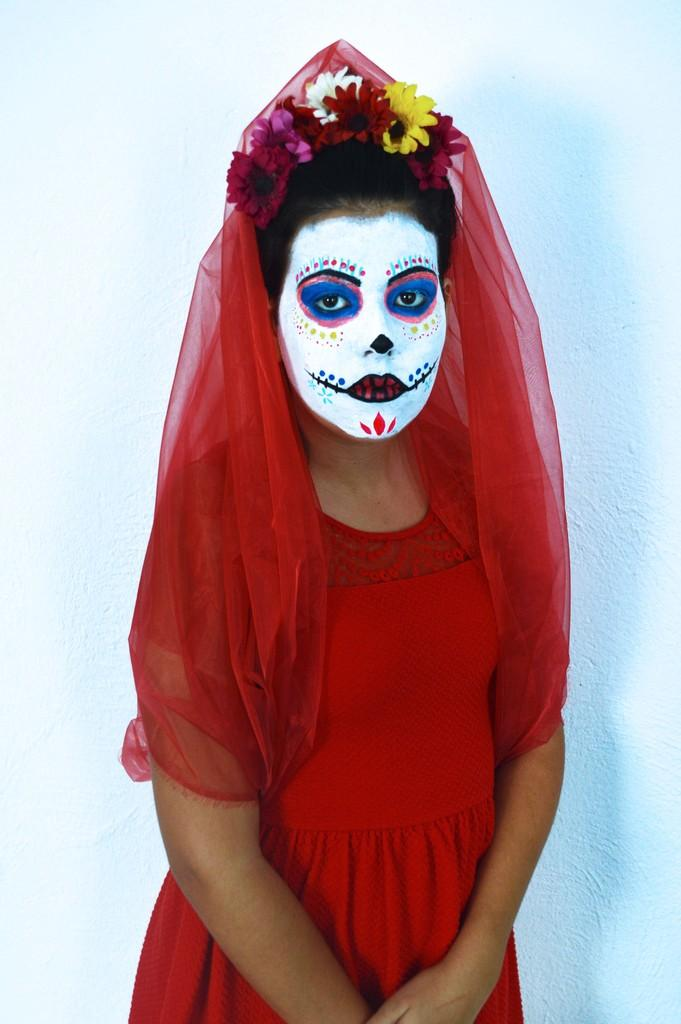What is the person in the image wearing? The person is wearing a red costume in the image. What accessory is the person wearing on their head? The person is wearing a flower crown on their head. What can be seen in the background of the image? There is a white wall in the background of the image. What type of shirt is covering the end of the white wall in the image? There is no shirt or any object covering the end of the white wall in the image. 